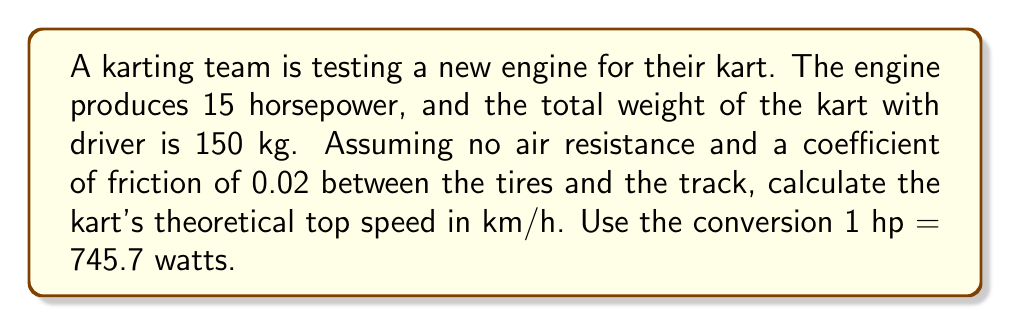Teach me how to tackle this problem. Let's approach this step-by-step:

1) First, convert horsepower to watts:
   $15 \text{ hp} \times 745.7 \text{ W/hp} = 11185.5 \text{ W}$

2) The force of friction is given by:
   $F_f = \mu N = \mu mg$
   where $\mu$ is the coefficient of friction, $m$ is the mass, and $g$ is the acceleration due to gravity (9.81 m/s²).
   
   $F_f = 0.02 \times 150 \text{ kg} \times 9.81 \text{ m/s}^2 = 29.43 \text{ N}$

3) At top speed, the power output of the engine equals the power required to overcome friction:
   $P = F_f v$
   where $P$ is power in watts, $F_f$ is the force of friction, and $v$ is velocity.

4) Rearrange to solve for $v$:
   $v = \frac{P}{F_f} = \frac{11185.5 \text{ W}}{29.43 \text{ N}} = 380.07 \text{ m/s}$

5) Convert m/s to km/h:
   $380.07 \text{ m/s} \times \frac{3600 \text{ s}}{1 \text{ h}} \times \frac{1 \text{ km}}{1000 \text{ m}} = 1368.25 \text{ km/h}$

Therefore, the theoretical top speed of the kart is approximately 1368 km/h.
Answer: 1368 km/h 